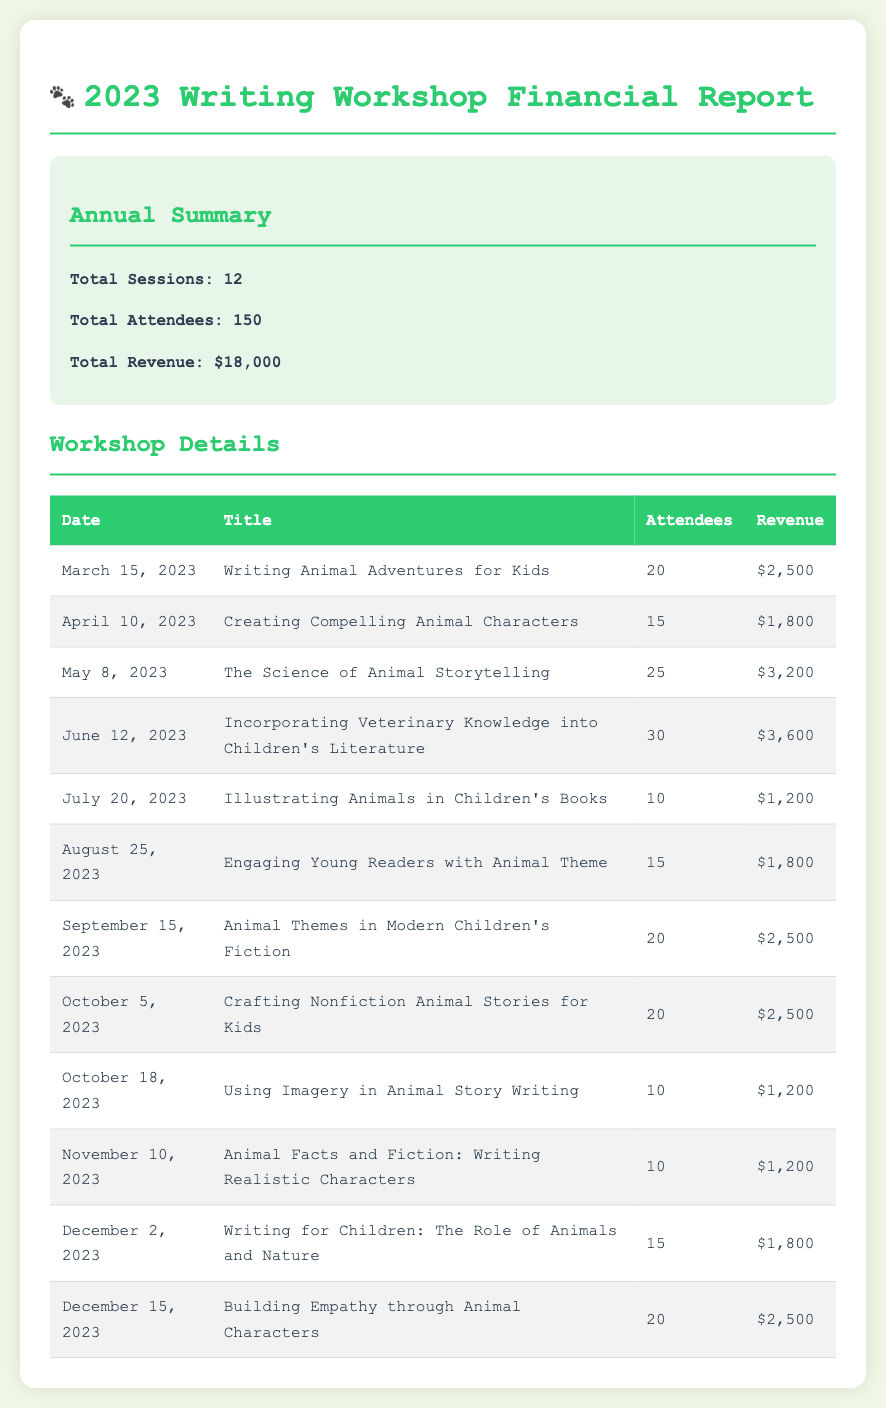What is the total revenue? The total revenue is stated in the document as $18,000.
Answer: $18,000 How many animal-themed sessions were conducted? The document specifies that there were 12 total sessions, and all were focused on animal themes.
Answer: 12 Which workshop had the highest attendance? The workshop titled "Incorporating Veterinary Knowledge into Children's Literature" had the highest number of attendees with 30 participants.
Answer: 30 What was the revenue generated from "Crafting Nonfiction Animal Stories for Kids"? The revenue for this specific workshop is mentioned as $2,500.
Answer: $2,500 On which date was the "Writing Animal Adventures for Kids" workshop held? The date of this workshop is listed as March 15, 2023.
Answer: March 15, 2023 What is the total number of attendees across all sessions? The document indicates that the total number of attendees is 150.
Answer: 150 Which month had the "Animal Facts and Fiction: Writing Realistic Characters" workshop? This workshop took place in November, as listed in the document.
Answer: November What was the revenue generated from the least attended workshop? The least attended workshop, "Illustrating Animals in Children's Books", generated $1,200.
Answer: $1,200 How many sessions focused specifically on "Building Empathy through Animal Characters"? The document states that there was one session dedicated to this topic.
Answer: 1 